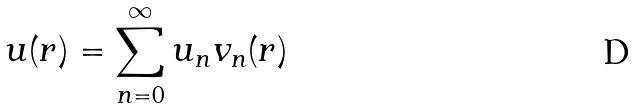<formula> <loc_0><loc_0><loc_500><loc_500>u ( r ) = \sum _ { n = 0 } ^ { \infty } u _ { n } v _ { n } ( r )</formula> 